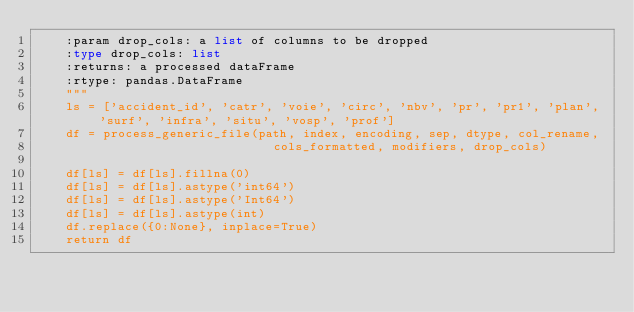Convert code to text. <code><loc_0><loc_0><loc_500><loc_500><_Python_>    :param drop_cols: a list of columns to be dropped
    :type drop_cols: list
    :returns: a processed dataFrame
    :rtype: pandas.DataFrame
    """
    ls = ['accident_id', 'catr', 'voie', 'circ', 'nbv', 'pr', 'pr1', 'plan', 'surf', 'infra', 'situ', 'vosp', 'prof']
    df = process_generic_file(path, index, encoding, sep, dtype, col_rename,
                                cols_formatted, modifiers, drop_cols)

    df[ls] = df[ls].fillna(0)
    df[ls] = df[ls].astype('int64')
    df[ls] = df[ls].astype('Int64')
    df[ls] = df[ls].astype(int)
    df.replace({0:None}, inplace=True)
    return df
</code> 